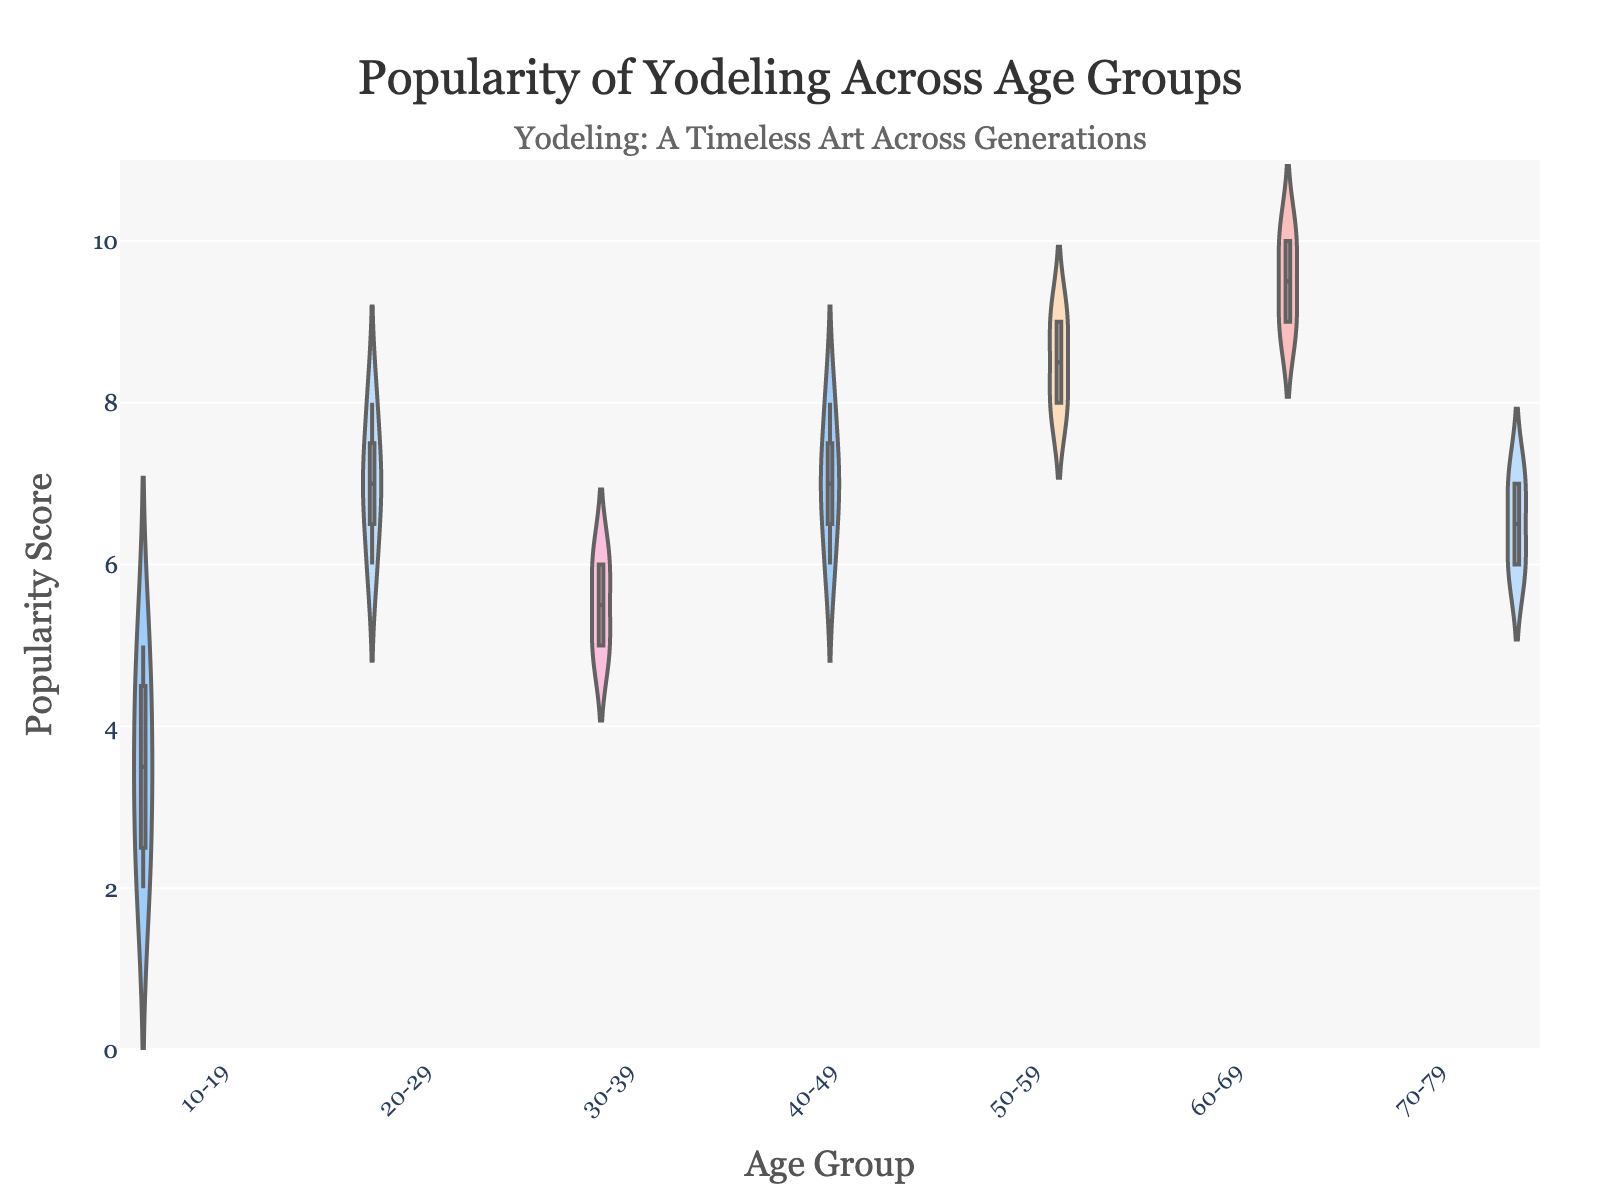What is the title of the figure? The title of the figure is located at the top and is in larger font compared to the other text elements. By reading the text, we can identify the title.
Answer: Popularity of Yodeling Across Age Groups What is the y-axis labeled as? The y-axis label is usually positioned vertically along the y-axis. We can read this label directly from the figure.
Answer: Popularity Score Which age group has the highest median popularity score? The median value is represented by the central line in each violin plot. By comparing the values of these lines across all age groups, we can determine the group with the highest median score.
Answer: 60-69 What is the range of popularity scores for the 50-59 age group? The range is indicated by the spread of the violin plot for the 50-59 age group, from the lowest to the highest data points.
Answer: 8-9 How does the distribution of the 70-79 age group compare to that of the 20-29 age group? The 70-79 age group has a narrower distribution with scores concentrated at 6-7, while the 20-29 age group has a wider distribution with scores from 6-8. We can see this by analyzing the spread and density of the violin plots for these groups.
Answer: Narrower and lower range Which age group shows the greatest variability in popularity scores? The greatest variability can be seen in the group with the widest spread in values within its violin plot. By visually comparing the spread of all groups, we can identify which has the most variability.
Answer: 20-29 What is the overall trend in popularity scores as age increases? By looking at the median lines within the violin plots and comparing them from the youngest age group to the oldest, we can infer the trend of increasing median scores.
Answer: Increasing Are there any age groups that have an equal mean popularity score? The mean value is shown by the meanline in the violin plots. By comparing these meanlines across all age groups, we can identify if any groups have the same mean score.
Answer: Yes, 40-49 and 50-59 have the same mean score Which age group appears to have the smallest spread of popularity scores? The smallest spread can be identified by the narrowest violin plot. By examining all plots, we can find the group with the tightest distribution of values.
Answer: 50-59 